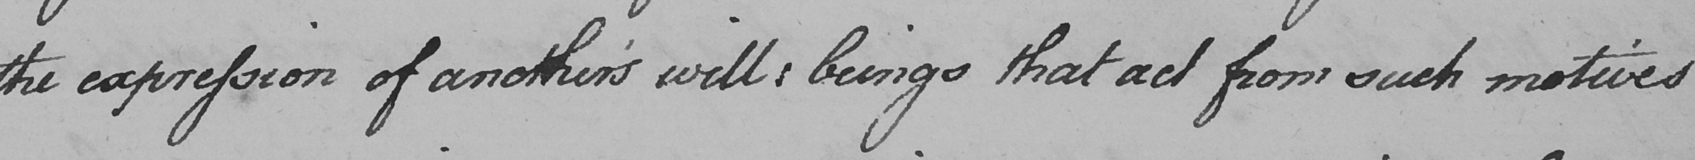What does this handwritten line say? the expression of another ' s will :  beings that act from such motives 